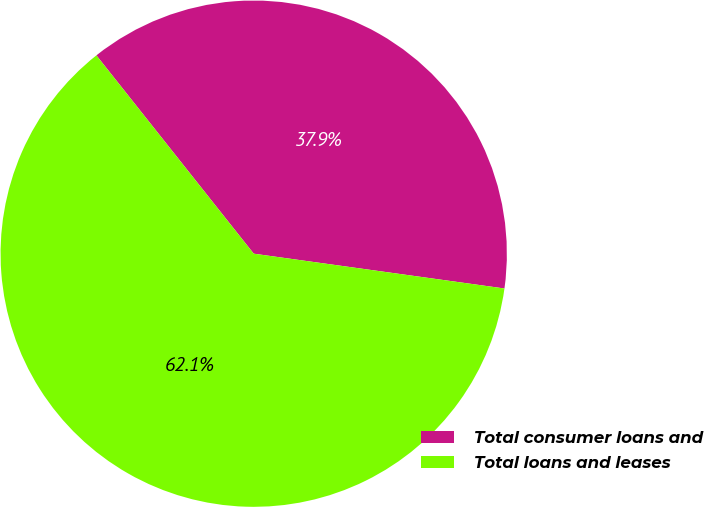Convert chart. <chart><loc_0><loc_0><loc_500><loc_500><pie_chart><fcel>Total consumer loans and<fcel>Total loans and leases<nl><fcel>37.87%<fcel>62.13%<nl></chart> 